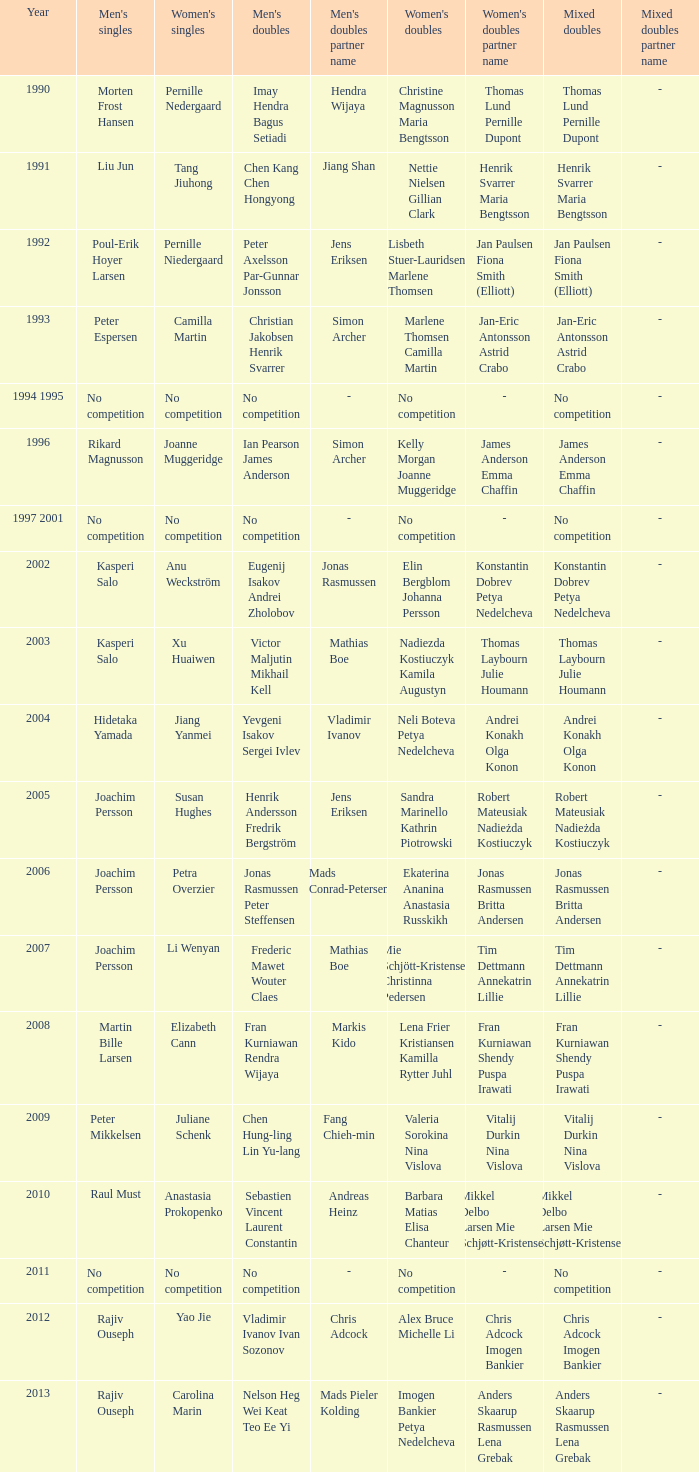Who won the Mixed doubles when Juliane Schenk won the Women's Singles? Vitalij Durkin Nina Vislova. 